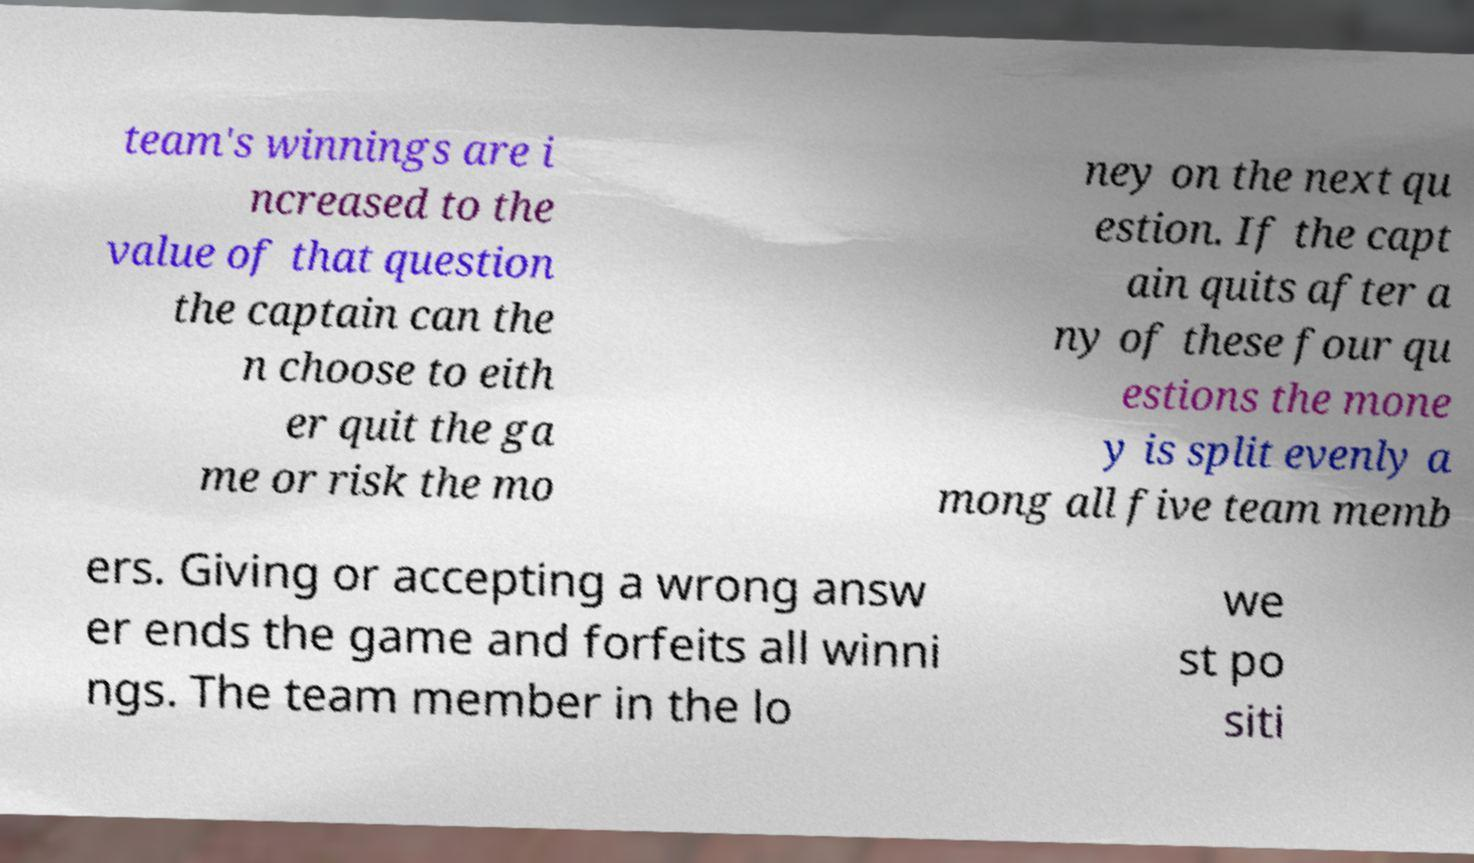I need the written content from this picture converted into text. Can you do that? team's winnings are i ncreased to the value of that question the captain can the n choose to eith er quit the ga me or risk the mo ney on the next qu estion. If the capt ain quits after a ny of these four qu estions the mone y is split evenly a mong all five team memb ers. Giving or accepting a wrong answ er ends the game and forfeits all winni ngs. The team member in the lo we st po siti 